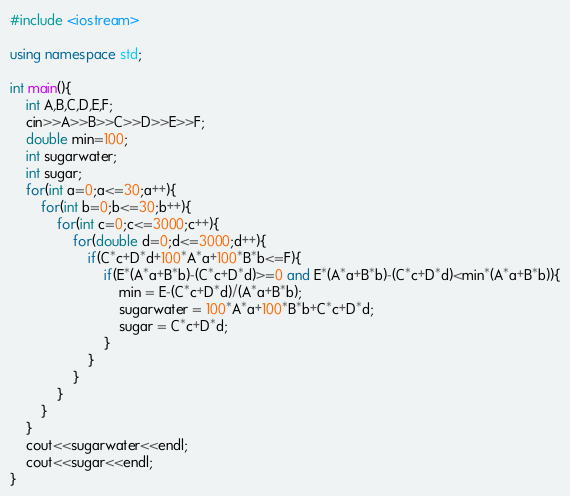<code> <loc_0><loc_0><loc_500><loc_500><_C++_>#include <iostream>

using namespace std;

int main(){
    int A,B,C,D,E,F;
    cin>>A>>B>>C>>D>>E>>F;
    double min=100;
    int sugarwater;
    int sugar;
    for(int a=0;a<=30;a++){
        for(int b=0;b<=30;b++){
            for(int c=0;c<=3000;c++){
                for(double d=0;d<=3000;d++){
                    if(C*c+D*d+100*A*a+100*B*b<=F){
                        if(E*(A*a+B*b)-(C*c+D*d)>=0 and E*(A*a+B*b)-(C*c+D*d)<min*(A*a+B*b)){
                            min = E-(C*c+D*d)/(A*a+B*b);
                            sugarwater = 100*A*a+100*B*b+C*c+D*d;
                            sugar = C*c+D*d;
                        }
                    }
                }
            }
        }
    }
    cout<<sugarwater<<endl;
    cout<<sugar<<endl;
}</code> 